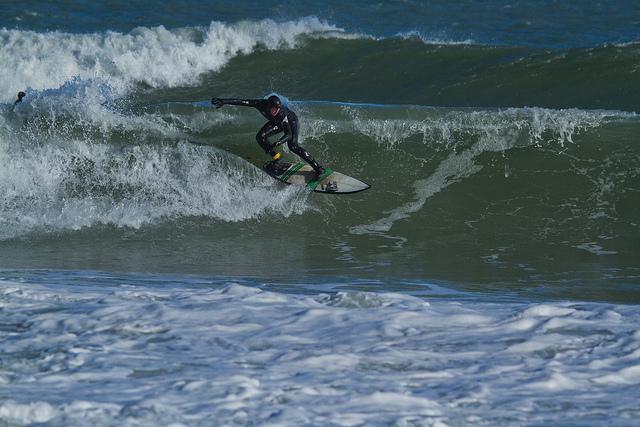How many surfers are in the picture?
Give a very brief answer. 1. How many people are in the picture?
Give a very brief answer. 1. 